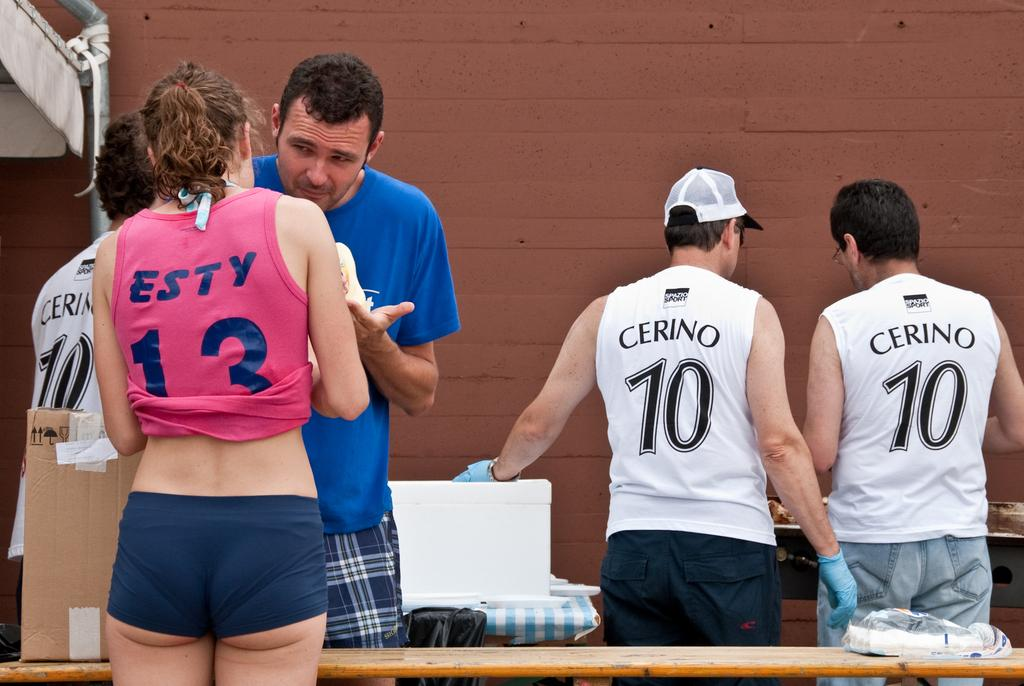<image>
Offer a succinct explanation of the picture presented. three cerino 10 male persons and one esty 13 female person heading towards the wall. 